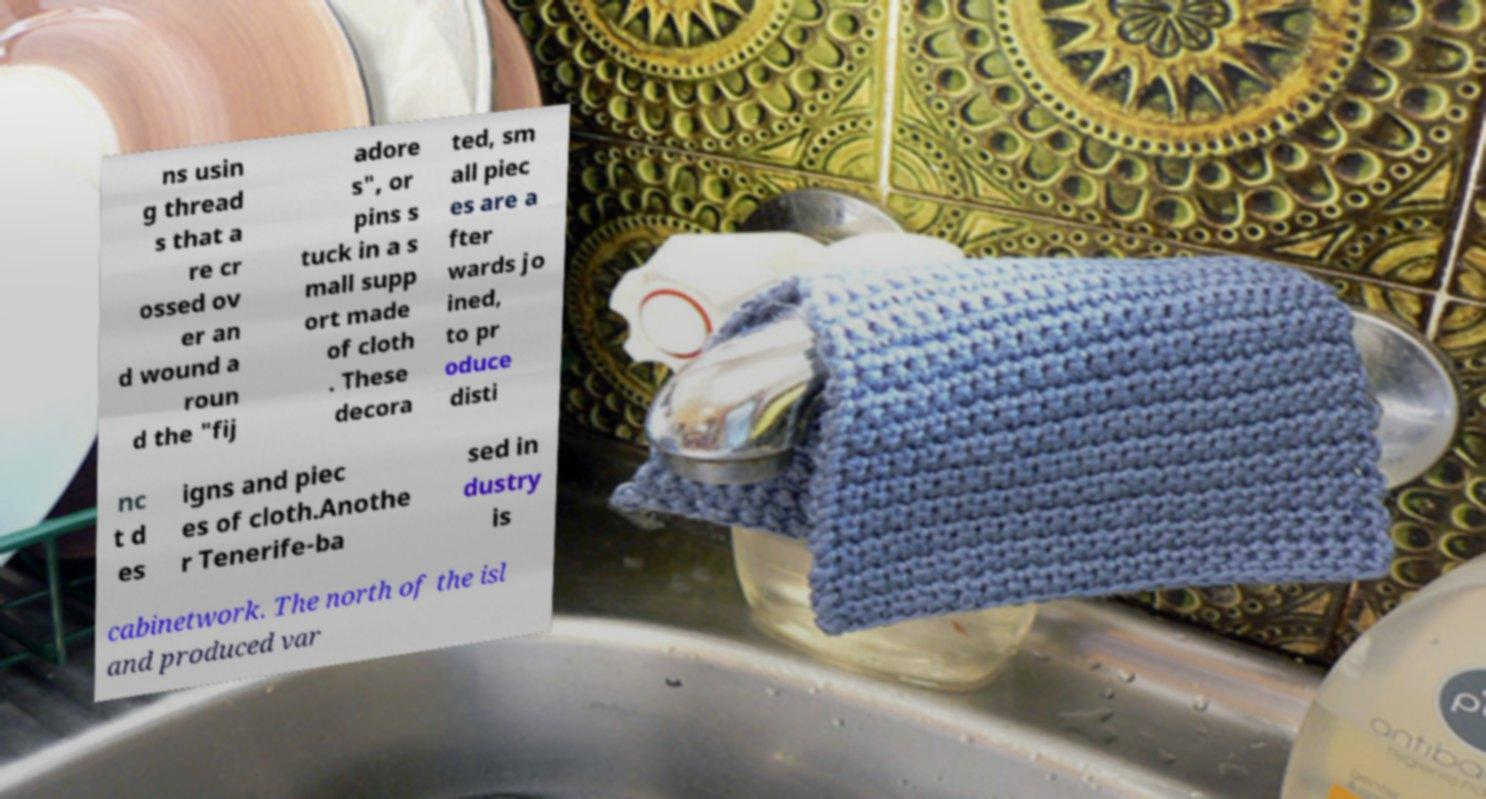Could you extract and type out the text from this image? ns usin g thread s that a re cr ossed ov er an d wound a roun d the "fij adore s", or pins s tuck in a s mall supp ort made of cloth . These decora ted, sm all piec es are a fter wards jo ined, to pr oduce disti nc t d es igns and piec es of cloth.Anothe r Tenerife-ba sed in dustry is cabinetwork. The north of the isl and produced var 